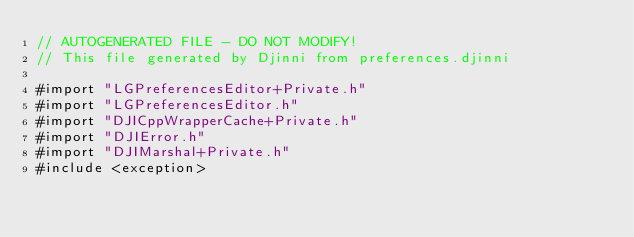<code> <loc_0><loc_0><loc_500><loc_500><_ObjectiveC_>// AUTOGENERATED FILE - DO NOT MODIFY!
// This file generated by Djinni from preferences.djinni

#import "LGPreferencesEditor+Private.h"
#import "LGPreferencesEditor.h"
#import "DJICppWrapperCache+Private.h"
#import "DJIError.h"
#import "DJIMarshal+Private.h"
#include <exception></code> 